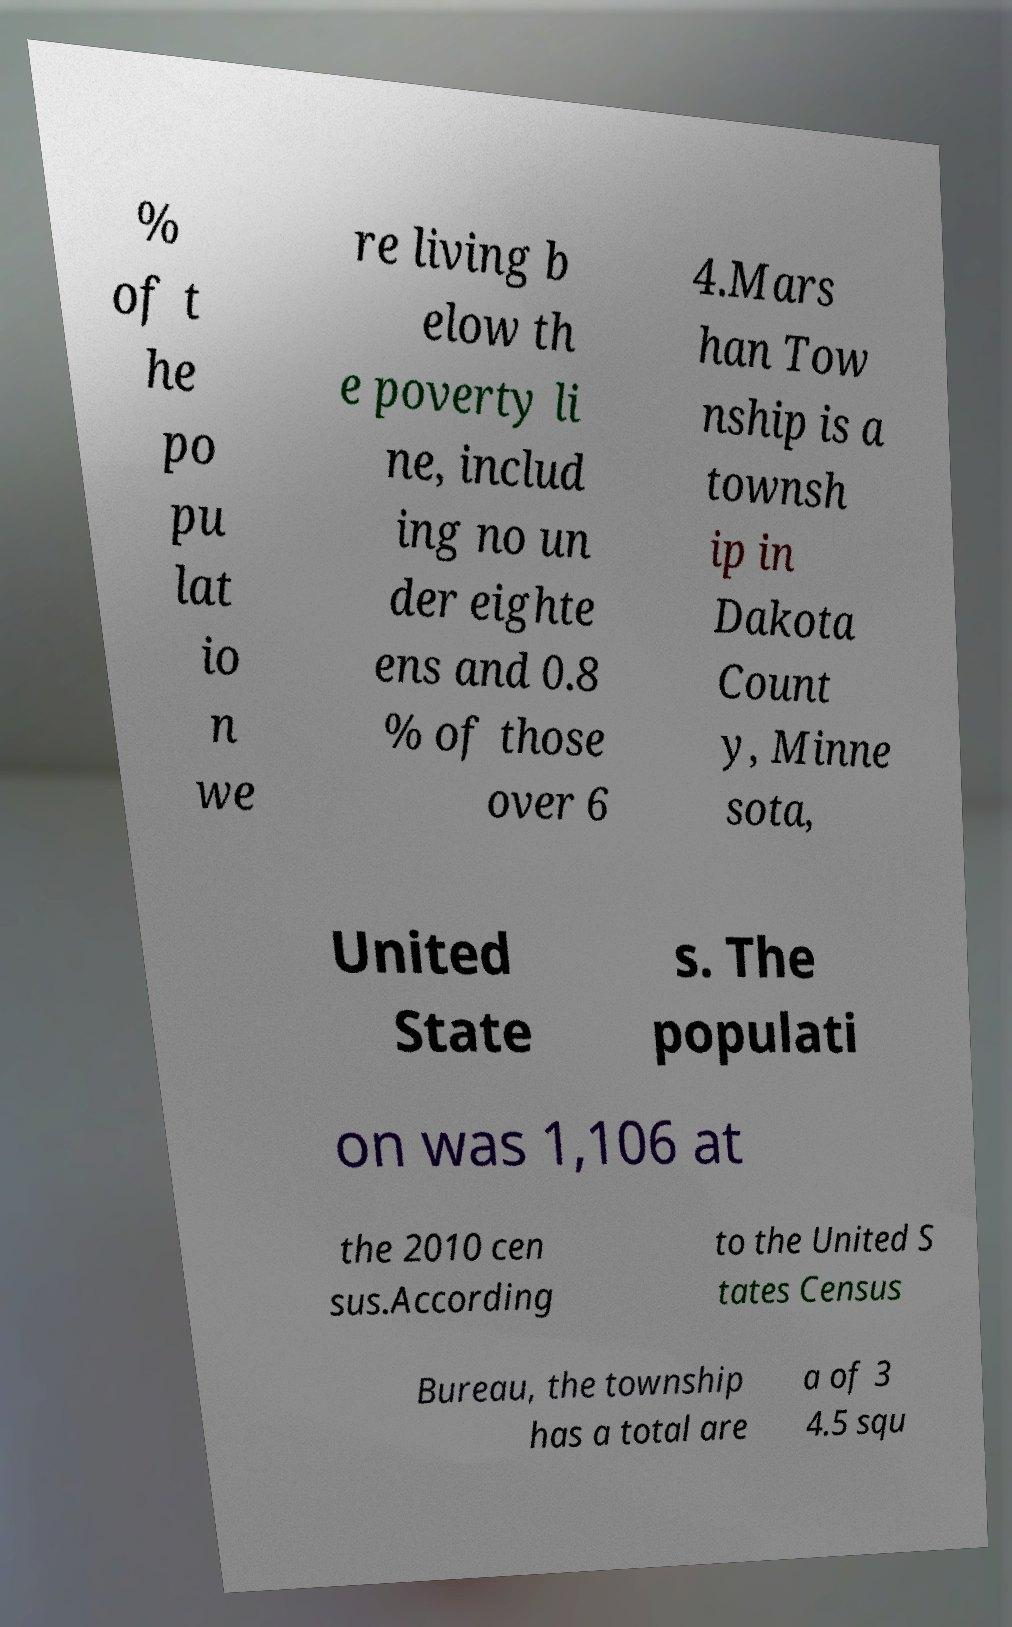Please read and relay the text visible in this image. What does it say? % of t he po pu lat io n we re living b elow th e poverty li ne, includ ing no un der eighte ens and 0.8 % of those over 6 4.Mars han Tow nship is a townsh ip in Dakota Count y, Minne sota, United State s. The populati on was 1,106 at the 2010 cen sus.According to the United S tates Census Bureau, the township has a total are a of 3 4.5 squ 